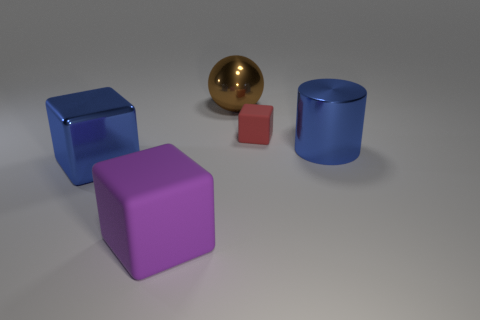Is the number of tiny red cubes that are left of the large blue cylinder greater than the number of blue things that are right of the brown metal sphere?
Your answer should be very brief. No. What is the material of the big cube that is the same color as the large cylinder?
Ensure brevity in your answer.  Metal. Is there any other thing that is the same shape as the brown metal thing?
Ensure brevity in your answer.  No. There is a cube that is both behind the purple rubber block and to the right of the shiny block; what is its material?
Offer a very short reply. Rubber. Are the brown thing and the big cube right of the large metallic block made of the same material?
Ensure brevity in your answer.  No. Are there any other things that have the same size as the red block?
Keep it short and to the point. No. What number of objects are either small blue matte blocks or large blue objects on the left side of the purple matte block?
Offer a very short reply. 1. Is the size of the rubber block to the left of the small rubber object the same as the blue object that is to the left of the blue cylinder?
Give a very brief answer. Yes. What number of other things are there of the same color as the large metallic sphere?
Give a very brief answer. 0. There is a cylinder; does it have the same size as the rubber cube on the right side of the big sphere?
Provide a short and direct response. No. 